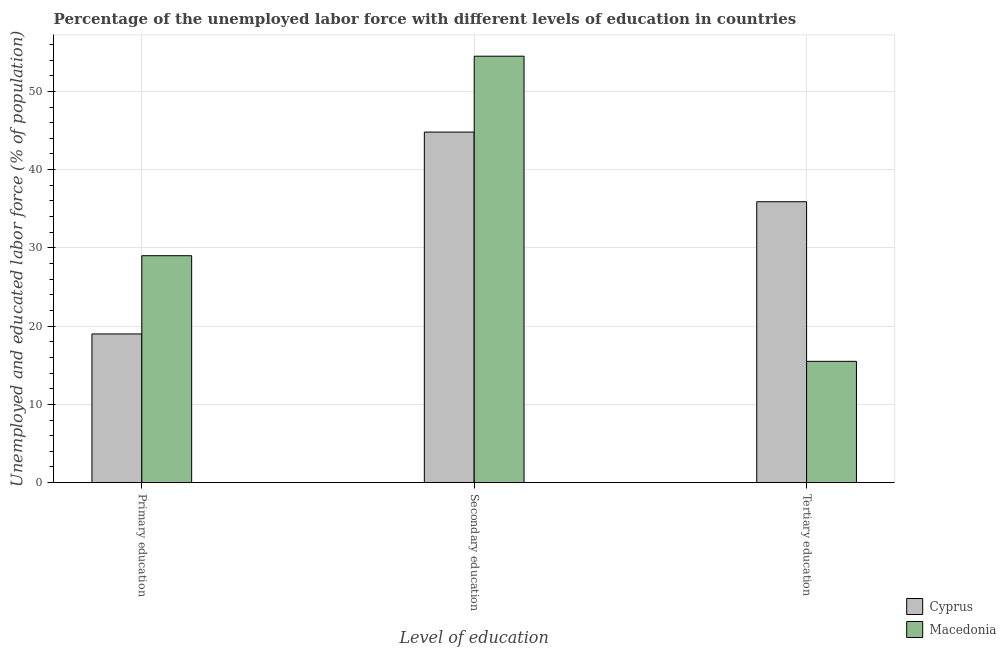Are the number of bars per tick equal to the number of legend labels?
Keep it short and to the point. Yes. Are the number of bars on each tick of the X-axis equal?
Your response must be concise. Yes. How many bars are there on the 2nd tick from the right?
Keep it short and to the point. 2. What is the label of the 3rd group of bars from the left?
Your response must be concise. Tertiary education. What is the percentage of labor force who received tertiary education in Macedonia?
Provide a short and direct response. 15.5. Across all countries, what is the maximum percentage of labor force who received secondary education?
Provide a short and direct response. 54.5. Across all countries, what is the minimum percentage of labor force who received secondary education?
Your answer should be very brief. 44.8. In which country was the percentage of labor force who received tertiary education maximum?
Make the answer very short. Cyprus. In which country was the percentage of labor force who received tertiary education minimum?
Your answer should be compact. Macedonia. What is the total percentage of labor force who received secondary education in the graph?
Provide a succinct answer. 99.3. What is the difference between the percentage of labor force who received secondary education in Cyprus and that in Macedonia?
Ensure brevity in your answer.  -9.7. What is the difference between the percentage of labor force who received tertiary education in Cyprus and the percentage of labor force who received primary education in Macedonia?
Your answer should be very brief. 6.9. What is the difference between the percentage of labor force who received tertiary education and percentage of labor force who received primary education in Cyprus?
Ensure brevity in your answer.  16.9. In how many countries, is the percentage of labor force who received tertiary education greater than 24 %?
Offer a terse response. 1. What is the ratio of the percentage of labor force who received secondary education in Cyprus to that in Macedonia?
Keep it short and to the point. 0.82. Is the difference between the percentage of labor force who received tertiary education in Cyprus and Macedonia greater than the difference between the percentage of labor force who received secondary education in Cyprus and Macedonia?
Offer a terse response. Yes. What is the difference between the highest and the second highest percentage of labor force who received tertiary education?
Provide a short and direct response. 20.4. What is the difference between the highest and the lowest percentage of labor force who received tertiary education?
Give a very brief answer. 20.4. Is the sum of the percentage of labor force who received tertiary education in Macedonia and Cyprus greater than the maximum percentage of labor force who received secondary education across all countries?
Give a very brief answer. No. What does the 2nd bar from the left in Secondary education represents?
Provide a short and direct response. Macedonia. What does the 2nd bar from the right in Primary education represents?
Your answer should be very brief. Cyprus. Are all the bars in the graph horizontal?
Offer a very short reply. No. What is the difference between two consecutive major ticks on the Y-axis?
Provide a short and direct response. 10. Are the values on the major ticks of Y-axis written in scientific E-notation?
Keep it short and to the point. No. What is the title of the graph?
Give a very brief answer. Percentage of the unemployed labor force with different levels of education in countries. Does "Greenland" appear as one of the legend labels in the graph?
Make the answer very short. No. What is the label or title of the X-axis?
Provide a short and direct response. Level of education. What is the label or title of the Y-axis?
Provide a succinct answer. Unemployed and educated labor force (% of population). What is the Unemployed and educated labor force (% of population) in Macedonia in Primary education?
Your answer should be very brief. 29. What is the Unemployed and educated labor force (% of population) of Cyprus in Secondary education?
Provide a succinct answer. 44.8. What is the Unemployed and educated labor force (% of population) in Macedonia in Secondary education?
Offer a terse response. 54.5. What is the Unemployed and educated labor force (% of population) of Cyprus in Tertiary education?
Offer a terse response. 35.9. What is the Unemployed and educated labor force (% of population) of Macedonia in Tertiary education?
Your response must be concise. 15.5. Across all Level of education, what is the maximum Unemployed and educated labor force (% of population) in Cyprus?
Provide a short and direct response. 44.8. Across all Level of education, what is the maximum Unemployed and educated labor force (% of population) of Macedonia?
Offer a very short reply. 54.5. Across all Level of education, what is the minimum Unemployed and educated labor force (% of population) of Cyprus?
Your answer should be compact. 19. Across all Level of education, what is the minimum Unemployed and educated labor force (% of population) in Macedonia?
Your answer should be very brief. 15.5. What is the total Unemployed and educated labor force (% of population) in Cyprus in the graph?
Your answer should be very brief. 99.7. What is the difference between the Unemployed and educated labor force (% of population) in Cyprus in Primary education and that in Secondary education?
Your response must be concise. -25.8. What is the difference between the Unemployed and educated labor force (% of population) in Macedonia in Primary education and that in Secondary education?
Provide a succinct answer. -25.5. What is the difference between the Unemployed and educated labor force (% of population) in Cyprus in Primary education and that in Tertiary education?
Give a very brief answer. -16.9. What is the difference between the Unemployed and educated labor force (% of population) in Cyprus in Secondary education and that in Tertiary education?
Make the answer very short. 8.9. What is the difference between the Unemployed and educated labor force (% of population) of Macedonia in Secondary education and that in Tertiary education?
Offer a terse response. 39. What is the difference between the Unemployed and educated labor force (% of population) in Cyprus in Primary education and the Unemployed and educated labor force (% of population) in Macedonia in Secondary education?
Your answer should be very brief. -35.5. What is the difference between the Unemployed and educated labor force (% of population) of Cyprus in Secondary education and the Unemployed and educated labor force (% of population) of Macedonia in Tertiary education?
Your response must be concise. 29.3. What is the average Unemployed and educated labor force (% of population) in Cyprus per Level of education?
Your answer should be compact. 33.23. What is the difference between the Unemployed and educated labor force (% of population) of Cyprus and Unemployed and educated labor force (% of population) of Macedonia in Primary education?
Give a very brief answer. -10. What is the difference between the Unemployed and educated labor force (% of population) in Cyprus and Unemployed and educated labor force (% of population) in Macedonia in Secondary education?
Offer a terse response. -9.7. What is the difference between the Unemployed and educated labor force (% of population) in Cyprus and Unemployed and educated labor force (% of population) in Macedonia in Tertiary education?
Make the answer very short. 20.4. What is the ratio of the Unemployed and educated labor force (% of population) in Cyprus in Primary education to that in Secondary education?
Keep it short and to the point. 0.42. What is the ratio of the Unemployed and educated labor force (% of population) in Macedonia in Primary education to that in Secondary education?
Keep it short and to the point. 0.53. What is the ratio of the Unemployed and educated labor force (% of population) of Cyprus in Primary education to that in Tertiary education?
Give a very brief answer. 0.53. What is the ratio of the Unemployed and educated labor force (% of population) in Macedonia in Primary education to that in Tertiary education?
Keep it short and to the point. 1.87. What is the ratio of the Unemployed and educated labor force (% of population) in Cyprus in Secondary education to that in Tertiary education?
Offer a terse response. 1.25. What is the ratio of the Unemployed and educated labor force (% of population) of Macedonia in Secondary education to that in Tertiary education?
Your answer should be compact. 3.52. What is the difference between the highest and the second highest Unemployed and educated labor force (% of population) in Cyprus?
Ensure brevity in your answer.  8.9. What is the difference between the highest and the second highest Unemployed and educated labor force (% of population) in Macedonia?
Offer a terse response. 25.5. What is the difference between the highest and the lowest Unemployed and educated labor force (% of population) of Cyprus?
Your answer should be very brief. 25.8. What is the difference between the highest and the lowest Unemployed and educated labor force (% of population) in Macedonia?
Provide a succinct answer. 39. 